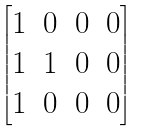Convert formula to latex. <formula><loc_0><loc_0><loc_500><loc_500>\begin{bmatrix} 1 & 0 & 0 & 0 \\ 1 & 1 & 0 & 0 \\ 1 & 0 & 0 & 0 \end{bmatrix}</formula> 